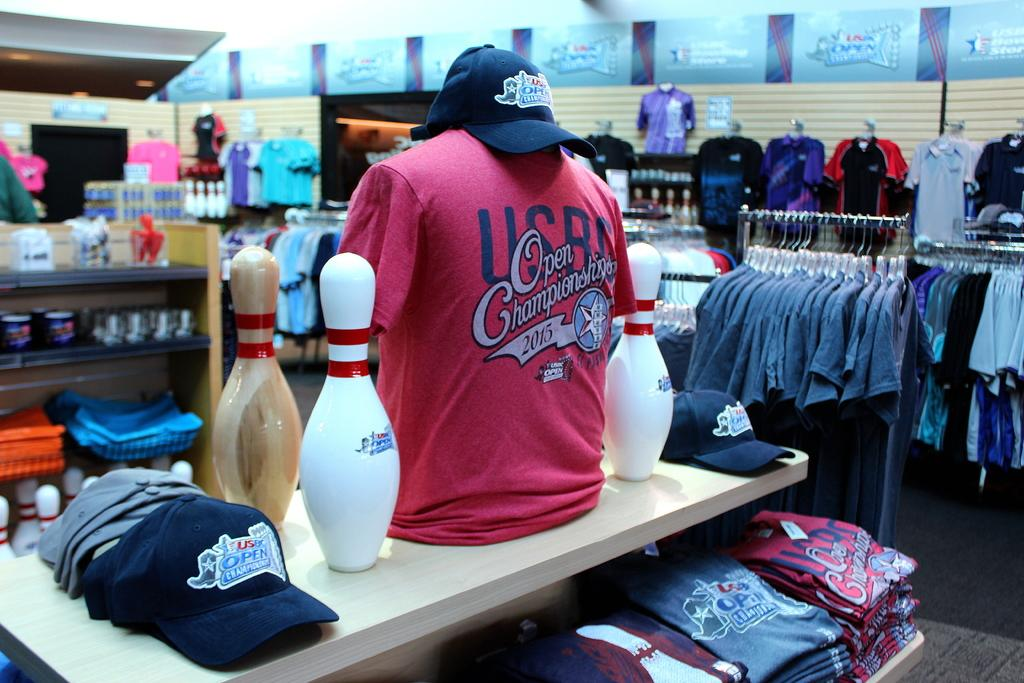<image>
Create a compact narrative representing the image presented. Merchandise for USBC Open Championships, including hats and shirts, are displayed in a store. 